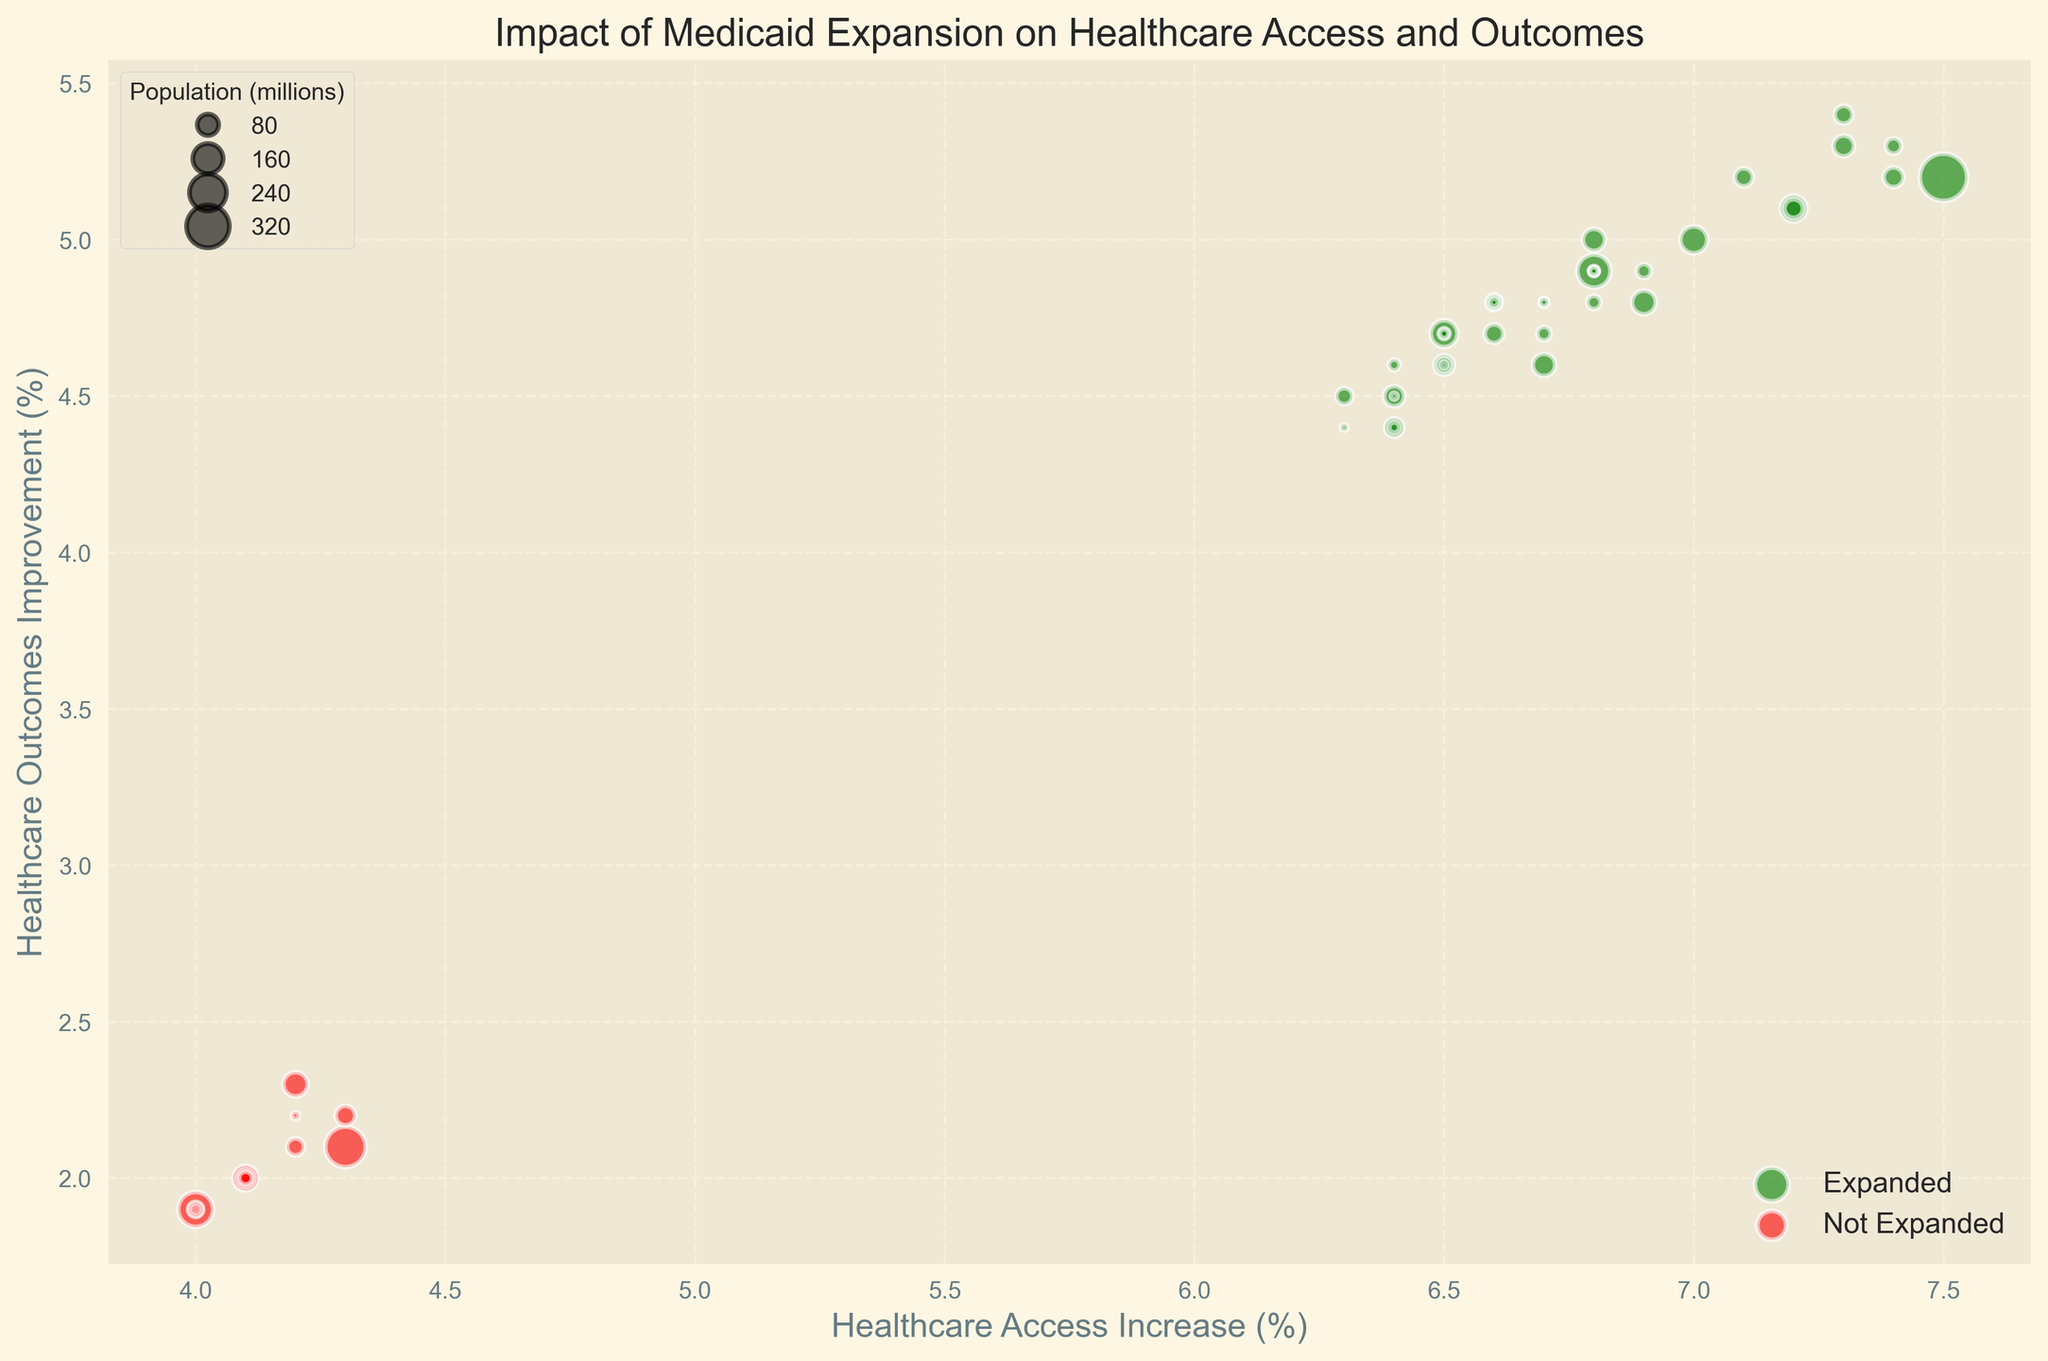Which states show the highest percentage increase in healthcare access? To find the state with the highest percentage increase in healthcare access, look for the state whose bubble is farthest to the right on the x-axis marked 'Healthcare Access Increase (%)'.
Answer: Washington and Oregon How do healthcare access and outcomes compare in states with Medicaid expansion versus those without? Compare the general positions of bubbles for states with Medicaid expansion (green) versus those without (red). Green bubbles tend to be further right and higher on the plot, indicating better outcomes.
Answer: States with Medicaid expansion generally have better access and outcomes Which state has the largest population and how is its healthcare performance? The size of the bubbles represents population. The largest bubble corresponds to California. Check its position on the plot.
Answer: California, with 7.5% increase in access and 5.2% improvement in outcomes If we consider states with an increase in healthcare access of more than 7%, how many states have also seen an improvement in healthcare outcomes above 5%? First, identify bubbles to the right of the 7% mark on the x-axis. Then, among those, count how many are above the 5% line on the y-axis.
Answer: Six states Which state without Medicaid expansion has the best healthcare outcomes improvement? Among the red bubbles, identify the one that is highest on the y-axis marked 'Healthcare Outcomes Improvement (%)'.
Answer: North Carolina Are there any states with a large population (>10 million) and low percentage increases in healthcare access (<5%)? Look for large bubbles (representing populations >10 million) located to the left of the 5% mark on the x-axis.
Answer: Texas, Florida, Georgia, North Carolina What is the average increase in healthcare access for states with Medicaid expansion? Identify and sum the healthcare access increases for green bubbles, then divide by the total number of green bubbles.
Answer: Approximately 6.8% What is the visual difference between states with and without Medicaid expansion in terms of bubble colors and locations? Note that Medicaid expansion states are represented by green bubbles, while states without are red. Typically, green bubbles are located further to the right and higher on the chart.
Answer: Green bubbles are generally higher and to the right, showing better access and outcomes 